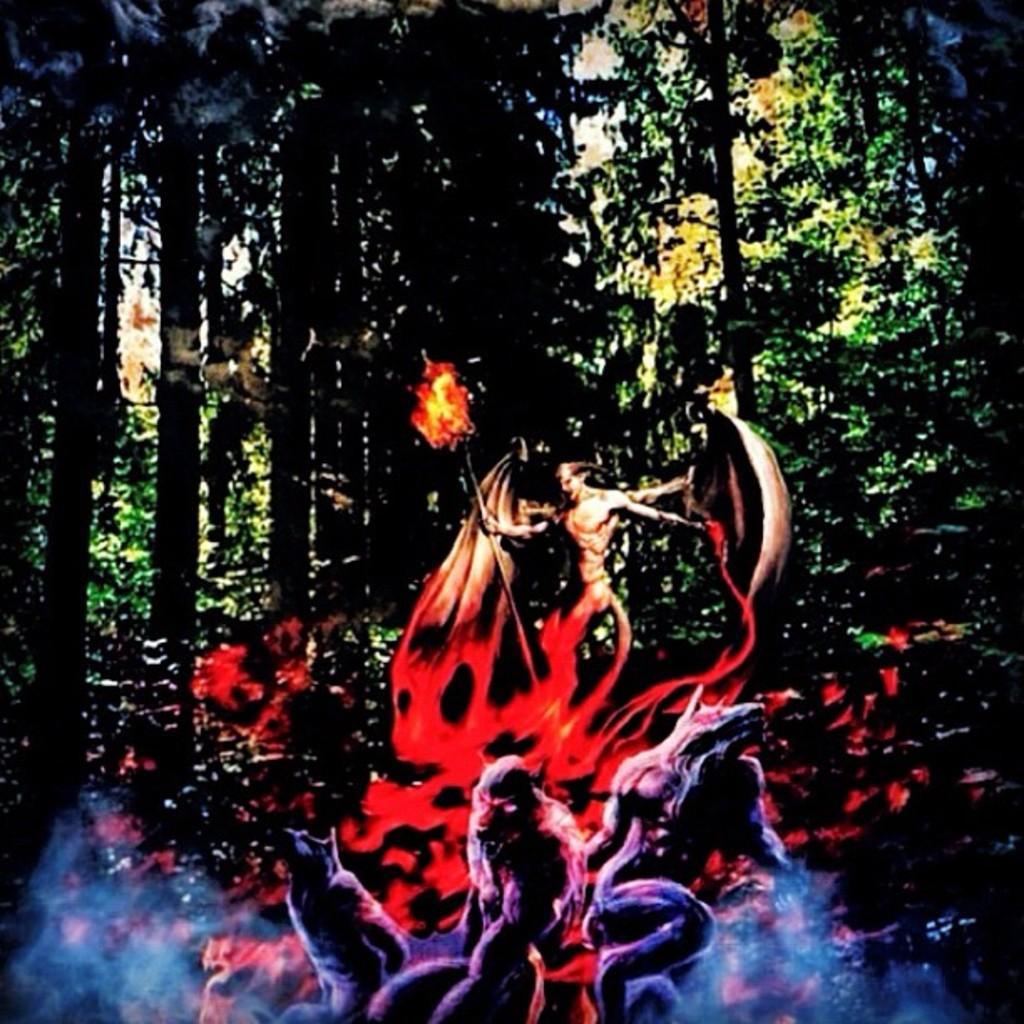In one or two sentences, can you explain what this image depicts? This is an animated picture. In this image, we can see a person holding a stick with fire. At the bottom of the image, we can see few animals. In the background, there are so many trees and plants. 